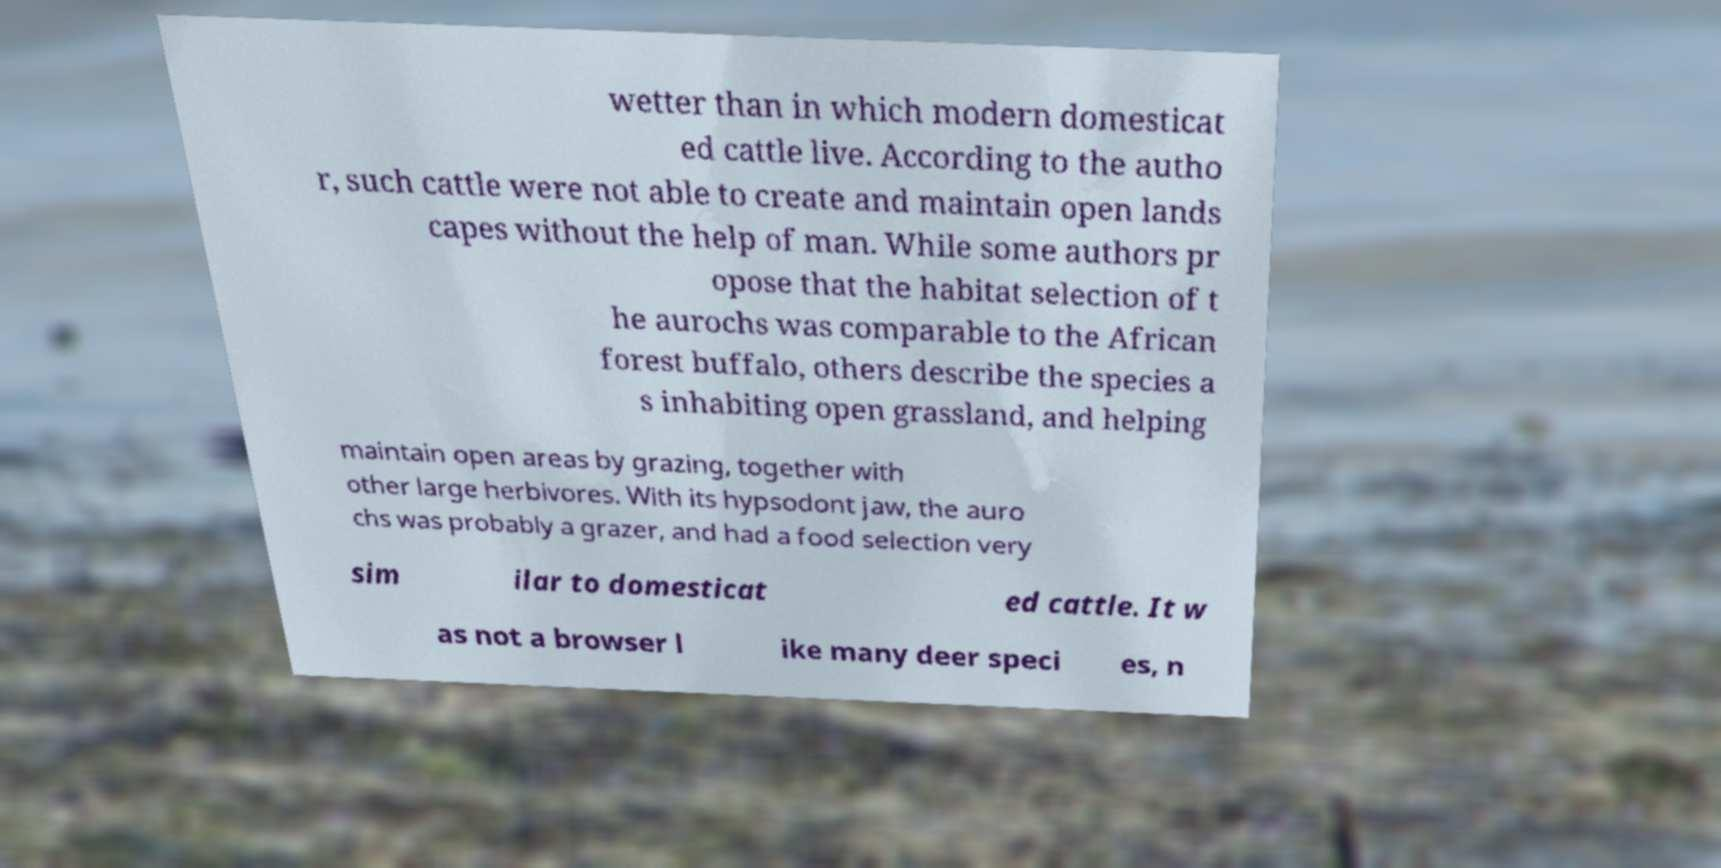Please identify and transcribe the text found in this image. wetter than in which modern domesticat ed cattle live. According to the autho r, such cattle were not able to create and maintain open lands capes without the help of man. While some authors pr opose that the habitat selection of t he aurochs was comparable to the African forest buffalo, others describe the species a s inhabiting open grassland, and helping maintain open areas by grazing, together with other large herbivores. With its hypsodont jaw, the auro chs was probably a grazer, and had a food selection very sim ilar to domesticat ed cattle. It w as not a browser l ike many deer speci es, n 